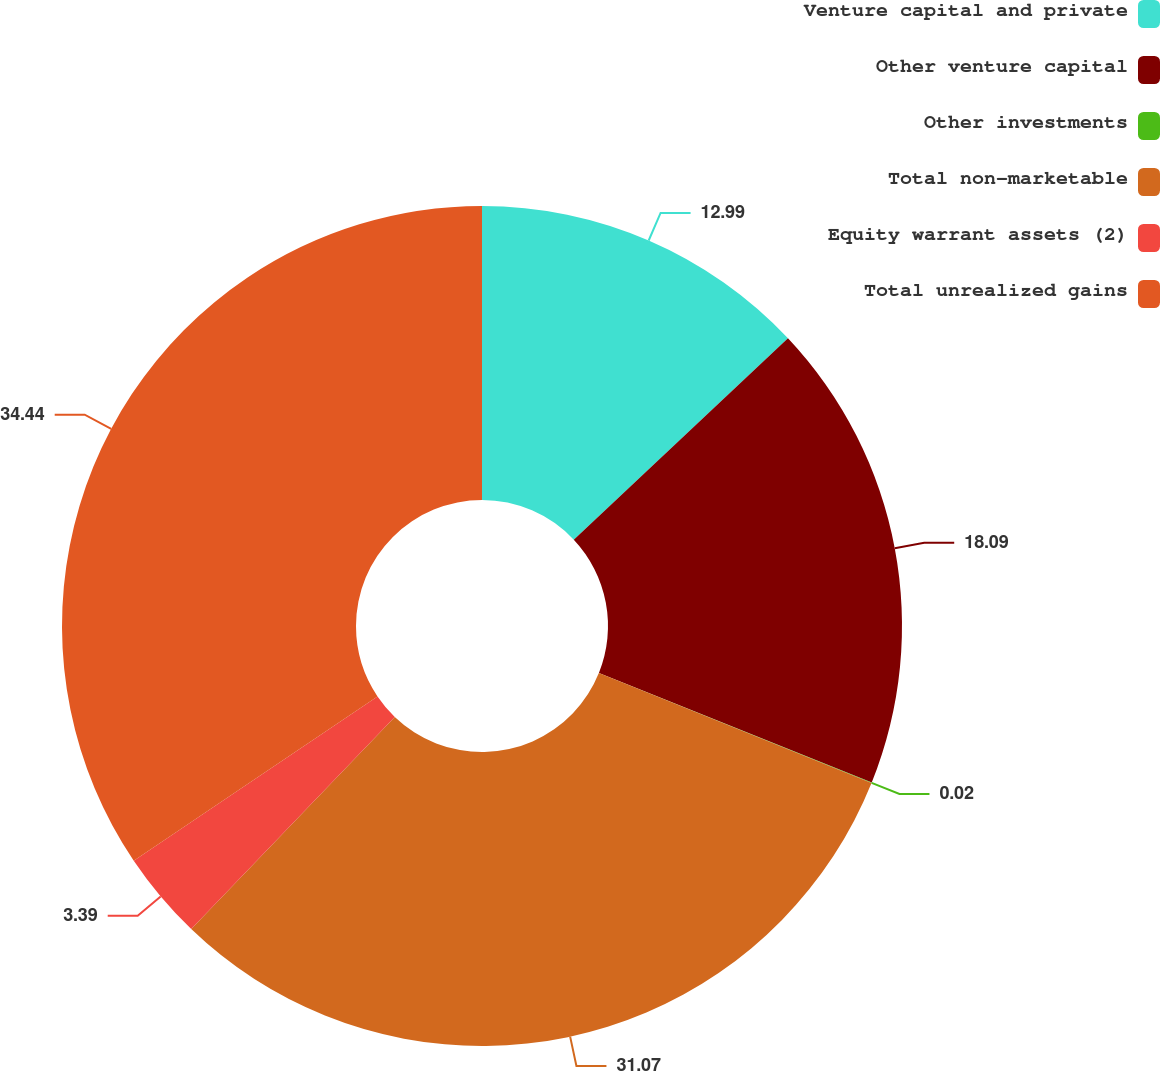Convert chart. <chart><loc_0><loc_0><loc_500><loc_500><pie_chart><fcel>Venture capital and private<fcel>Other venture capital<fcel>Other investments<fcel>Total non-marketable<fcel>Equity warrant assets (2)<fcel>Total unrealized gains<nl><fcel>12.99%<fcel>18.09%<fcel>0.02%<fcel>31.07%<fcel>3.39%<fcel>34.44%<nl></chart> 